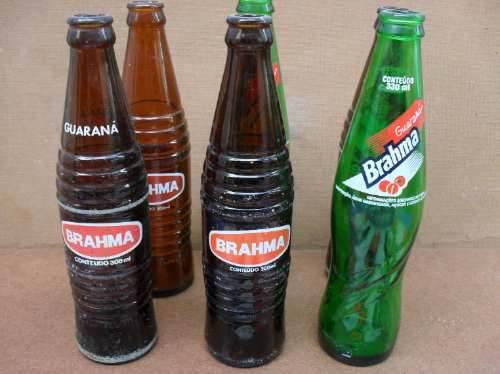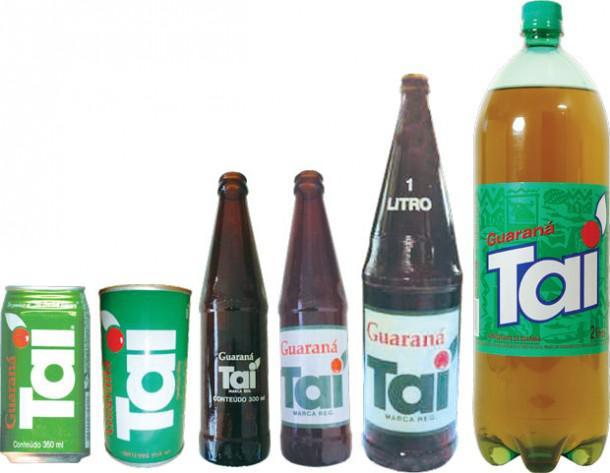The first image is the image on the left, the second image is the image on the right. Given the left and right images, does the statement "There are exactly two green bottles in the right image, and multiple green bottles with a clear bottle in the left image." hold true? Answer yes or no. No. The first image is the image on the left, the second image is the image on the right. Analyze the images presented: Is the assertion "Six or fewer bottles are visible." valid? Answer yes or no. No. 